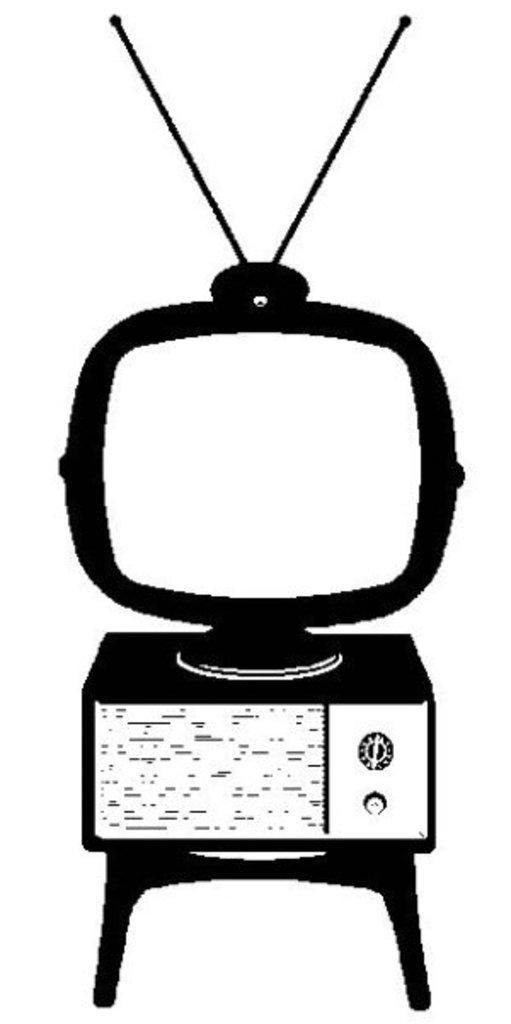Can you describe this image briefly? This is an animated picture of a television which is placed on a device and a stool. 